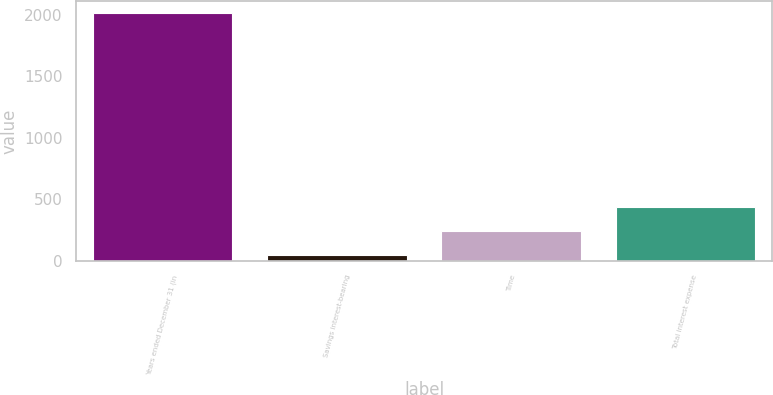<chart> <loc_0><loc_0><loc_500><loc_500><bar_chart><fcel>Years ended December 31 (in<fcel>Savings interest-bearing<fcel>Time<fcel>Total interest expense<nl><fcel>2011<fcel>51<fcel>247<fcel>443<nl></chart> 